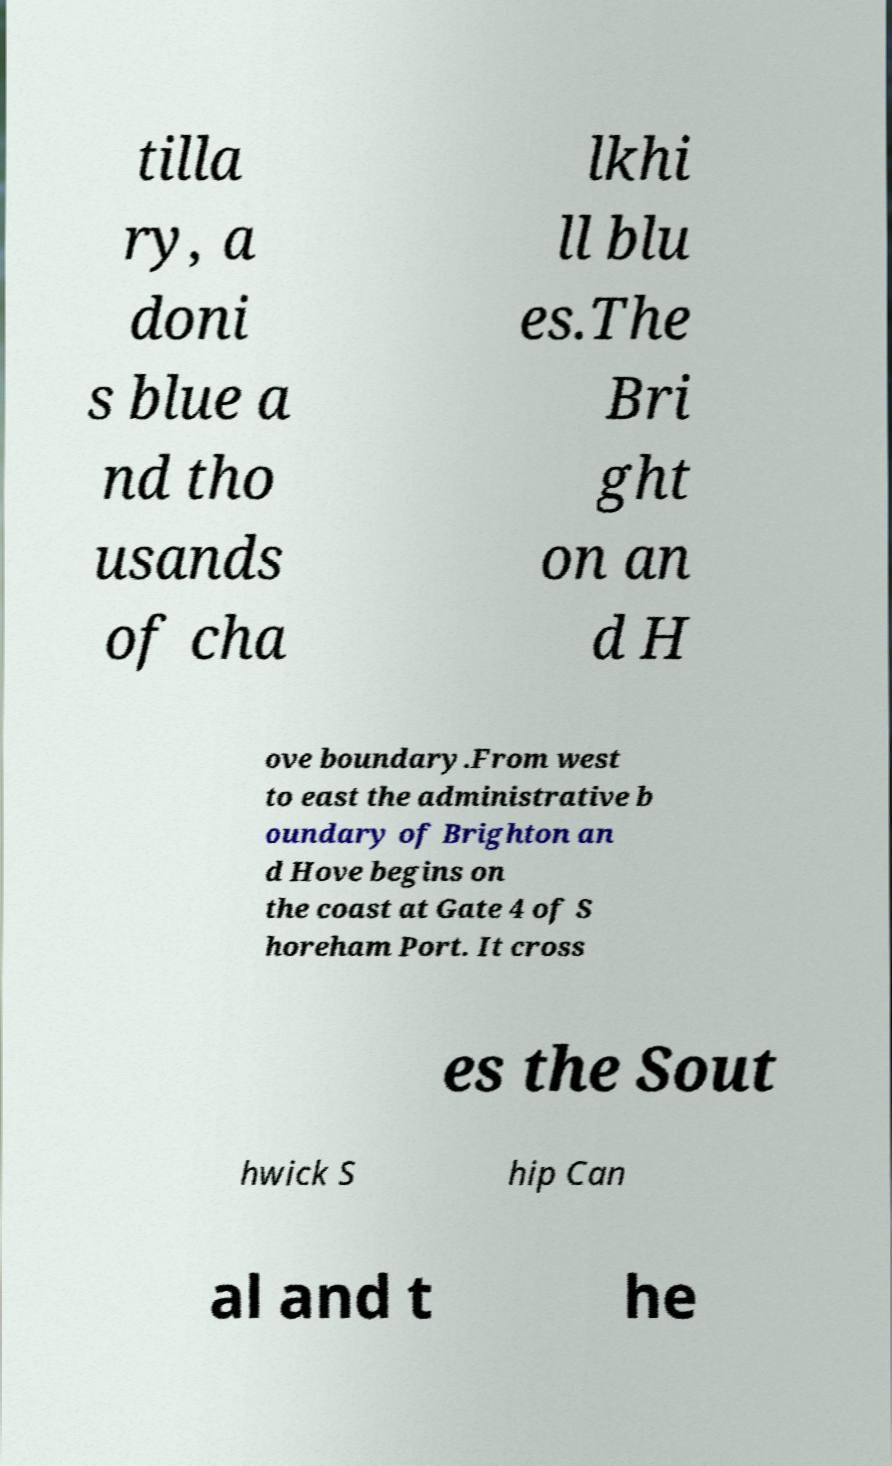Please read and relay the text visible in this image. What does it say? tilla ry, a doni s blue a nd tho usands of cha lkhi ll blu es.The Bri ght on an d H ove boundary.From west to east the administrative b oundary of Brighton an d Hove begins on the coast at Gate 4 of S horeham Port. It cross es the Sout hwick S hip Can al and t he 